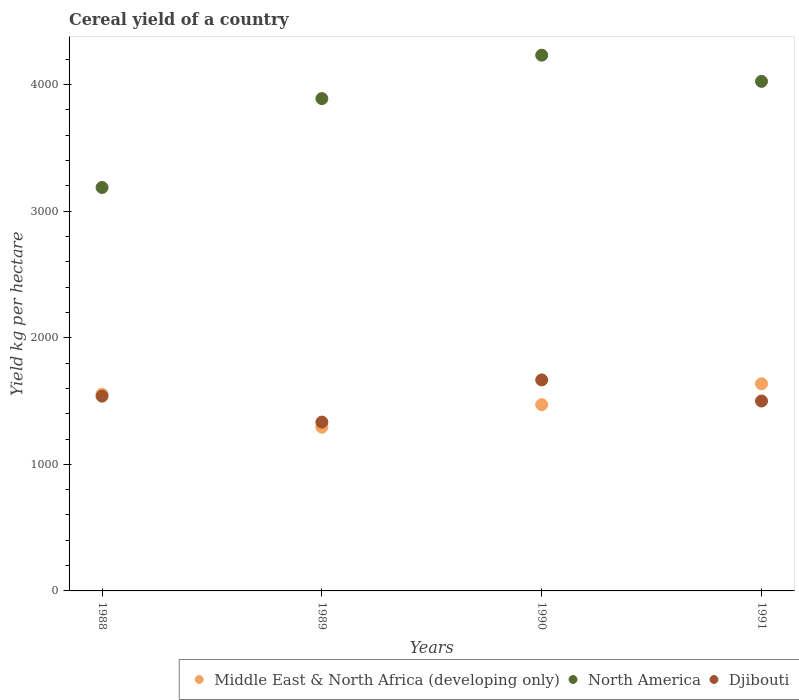Is the number of dotlines equal to the number of legend labels?
Ensure brevity in your answer.  Yes. What is the total cereal yield in Djibouti in 1991?
Offer a very short reply. 1500. Across all years, what is the maximum total cereal yield in Middle East & North Africa (developing only)?
Your answer should be compact. 1636.14. Across all years, what is the minimum total cereal yield in North America?
Offer a terse response. 3186.76. What is the total total cereal yield in North America in the graph?
Give a very brief answer. 1.53e+04. What is the difference between the total cereal yield in Middle East & North Africa (developing only) in 1988 and that in 1991?
Give a very brief answer. -82.48. What is the difference between the total cereal yield in Middle East & North Africa (developing only) in 1991 and the total cereal yield in Djibouti in 1990?
Offer a terse response. -30.53. What is the average total cereal yield in North America per year?
Ensure brevity in your answer.  3833.07. In the year 1991, what is the difference between the total cereal yield in Djibouti and total cereal yield in Middle East & North Africa (developing only)?
Ensure brevity in your answer.  -136.14. In how many years, is the total cereal yield in Middle East & North Africa (developing only) greater than 2200 kg per hectare?
Ensure brevity in your answer.  0. What is the ratio of the total cereal yield in Middle East & North Africa (developing only) in 1989 to that in 1991?
Keep it short and to the point. 0.79. Is the total cereal yield in Middle East & North Africa (developing only) in 1988 less than that in 1990?
Provide a succinct answer. No. Is the difference between the total cereal yield in Djibouti in 1990 and 1991 greater than the difference between the total cereal yield in Middle East & North Africa (developing only) in 1990 and 1991?
Your answer should be very brief. Yes. What is the difference between the highest and the second highest total cereal yield in Djibouti?
Provide a succinct answer. 128.2. What is the difference between the highest and the lowest total cereal yield in North America?
Your response must be concise. 1045.05. In how many years, is the total cereal yield in Djibouti greater than the average total cereal yield in Djibouti taken over all years?
Make the answer very short. 2. Is the sum of the total cereal yield in Djibouti in 1988 and 1990 greater than the maximum total cereal yield in North America across all years?
Give a very brief answer. No. Is the total cereal yield in Djibouti strictly greater than the total cereal yield in Middle East & North Africa (developing only) over the years?
Give a very brief answer. No. Is the total cereal yield in Middle East & North Africa (developing only) strictly less than the total cereal yield in North America over the years?
Ensure brevity in your answer.  Yes. How many years are there in the graph?
Keep it short and to the point. 4. Does the graph contain any zero values?
Provide a short and direct response. No. Does the graph contain grids?
Provide a short and direct response. No. How are the legend labels stacked?
Make the answer very short. Horizontal. What is the title of the graph?
Ensure brevity in your answer.  Cereal yield of a country. Does "Kosovo" appear as one of the legend labels in the graph?
Provide a succinct answer. No. What is the label or title of the Y-axis?
Provide a succinct answer. Yield kg per hectare. What is the Yield kg per hectare of Middle East & North Africa (developing only) in 1988?
Offer a very short reply. 1553.66. What is the Yield kg per hectare in North America in 1988?
Ensure brevity in your answer.  3186.76. What is the Yield kg per hectare of Djibouti in 1988?
Keep it short and to the point. 1538.46. What is the Yield kg per hectare in Middle East & North Africa (developing only) in 1989?
Provide a short and direct response. 1293.52. What is the Yield kg per hectare in North America in 1989?
Offer a very short reply. 3888.9. What is the Yield kg per hectare of Djibouti in 1989?
Offer a terse response. 1333.33. What is the Yield kg per hectare in Middle East & North Africa (developing only) in 1990?
Provide a short and direct response. 1471.14. What is the Yield kg per hectare of North America in 1990?
Your answer should be compact. 4231.81. What is the Yield kg per hectare in Djibouti in 1990?
Your response must be concise. 1666.67. What is the Yield kg per hectare of Middle East & North Africa (developing only) in 1991?
Your answer should be very brief. 1636.14. What is the Yield kg per hectare of North America in 1991?
Provide a short and direct response. 4024.81. What is the Yield kg per hectare in Djibouti in 1991?
Make the answer very short. 1500. Across all years, what is the maximum Yield kg per hectare in Middle East & North Africa (developing only)?
Provide a succinct answer. 1636.14. Across all years, what is the maximum Yield kg per hectare in North America?
Your response must be concise. 4231.81. Across all years, what is the maximum Yield kg per hectare in Djibouti?
Give a very brief answer. 1666.67. Across all years, what is the minimum Yield kg per hectare of Middle East & North Africa (developing only)?
Provide a short and direct response. 1293.52. Across all years, what is the minimum Yield kg per hectare in North America?
Offer a very short reply. 3186.76. Across all years, what is the minimum Yield kg per hectare in Djibouti?
Your answer should be compact. 1333.33. What is the total Yield kg per hectare of Middle East & North Africa (developing only) in the graph?
Your response must be concise. 5954.46. What is the total Yield kg per hectare of North America in the graph?
Give a very brief answer. 1.53e+04. What is the total Yield kg per hectare in Djibouti in the graph?
Give a very brief answer. 6038.46. What is the difference between the Yield kg per hectare of Middle East & North Africa (developing only) in 1988 and that in 1989?
Give a very brief answer. 260.14. What is the difference between the Yield kg per hectare in North America in 1988 and that in 1989?
Your answer should be compact. -702.13. What is the difference between the Yield kg per hectare of Djibouti in 1988 and that in 1989?
Offer a terse response. 205.13. What is the difference between the Yield kg per hectare in Middle East & North Africa (developing only) in 1988 and that in 1990?
Your response must be concise. 82.53. What is the difference between the Yield kg per hectare in North America in 1988 and that in 1990?
Offer a terse response. -1045.05. What is the difference between the Yield kg per hectare in Djibouti in 1988 and that in 1990?
Your answer should be compact. -128.21. What is the difference between the Yield kg per hectare in Middle East & North Africa (developing only) in 1988 and that in 1991?
Give a very brief answer. -82.48. What is the difference between the Yield kg per hectare in North America in 1988 and that in 1991?
Make the answer very short. -838.05. What is the difference between the Yield kg per hectare of Djibouti in 1988 and that in 1991?
Your answer should be very brief. 38.46. What is the difference between the Yield kg per hectare of Middle East & North Africa (developing only) in 1989 and that in 1990?
Keep it short and to the point. -177.61. What is the difference between the Yield kg per hectare in North America in 1989 and that in 1990?
Offer a very short reply. -342.92. What is the difference between the Yield kg per hectare of Djibouti in 1989 and that in 1990?
Give a very brief answer. -333.33. What is the difference between the Yield kg per hectare of Middle East & North Africa (developing only) in 1989 and that in 1991?
Your answer should be very brief. -342.62. What is the difference between the Yield kg per hectare in North America in 1989 and that in 1991?
Your answer should be very brief. -135.91. What is the difference between the Yield kg per hectare of Djibouti in 1989 and that in 1991?
Provide a short and direct response. -166.67. What is the difference between the Yield kg per hectare in Middle East & North Africa (developing only) in 1990 and that in 1991?
Give a very brief answer. -165. What is the difference between the Yield kg per hectare of North America in 1990 and that in 1991?
Keep it short and to the point. 207.01. What is the difference between the Yield kg per hectare in Djibouti in 1990 and that in 1991?
Your response must be concise. 166.67. What is the difference between the Yield kg per hectare in Middle East & North Africa (developing only) in 1988 and the Yield kg per hectare in North America in 1989?
Offer a terse response. -2335.24. What is the difference between the Yield kg per hectare in Middle East & North Africa (developing only) in 1988 and the Yield kg per hectare in Djibouti in 1989?
Give a very brief answer. 220.33. What is the difference between the Yield kg per hectare in North America in 1988 and the Yield kg per hectare in Djibouti in 1989?
Keep it short and to the point. 1853.43. What is the difference between the Yield kg per hectare in Middle East & North Africa (developing only) in 1988 and the Yield kg per hectare in North America in 1990?
Provide a succinct answer. -2678.15. What is the difference between the Yield kg per hectare of Middle East & North Africa (developing only) in 1988 and the Yield kg per hectare of Djibouti in 1990?
Make the answer very short. -113. What is the difference between the Yield kg per hectare of North America in 1988 and the Yield kg per hectare of Djibouti in 1990?
Ensure brevity in your answer.  1520.1. What is the difference between the Yield kg per hectare in Middle East & North Africa (developing only) in 1988 and the Yield kg per hectare in North America in 1991?
Offer a very short reply. -2471.15. What is the difference between the Yield kg per hectare of Middle East & North Africa (developing only) in 1988 and the Yield kg per hectare of Djibouti in 1991?
Make the answer very short. 53.66. What is the difference between the Yield kg per hectare of North America in 1988 and the Yield kg per hectare of Djibouti in 1991?
Offer a terse response. 1686.76. What is the difference between the Yield kg per hectare in Middle East & North Africa (developing only) in 1989 and the Yield kg per hectare in North America in 1990?
Keep it short and to the point. -2938.29. What is the difference between the Yield kg per hectare of Middle East & North Africa (developing only) in 1989 and the Yield kg per hectare of Djibouti in 1990?
Ensure brevity in your answer.  -373.14. What is the difference between the Yield kg per hectare of North America in 1989 and the Yield kg per hectare of Djibouti in 1990?
Offer a terse response. 2222.23. What is the difference between the Yield kg per hectare of Middle East & North Africa (developing only) in 1989 and the Yield kg per hectare of North America in 1991?
Your answer should be compact. -2731.29. What is the difference between the Yield kg per hectare of Middle East & North Africa (developing only) in 1989 and the Yield kg per hectare of Djibouti in 1991?
Your answer should be very brief. -206.48. What is the difference between the Yield kg per hectare in North America in 1989 and the Yield kg per hectare in Djibouti in 1991?
Your response must be concise. 2388.9. What is the difference between the Yield kg per hectare of Middle East & North Africa (developing only) in 1990 and the Yield kg per hectare of North America in 1991?
Keep it short and to the point. -2553.67. What is the difference between the Yield kg per hectare of Middle East & North Africa (developing only) in 1990 and the Yield kg per hectare of Djibouti in 1991?
Ensure brevity in your answer.  -28.86. What is the difference between the Yield kg per hectare of North America in 1990 and the Yield kg per hectare of Djibouti in 1991?
Your response must be concise. 2731.81. What is the average Yield kg per hectare of Middle East & North Africa (developing only) per year?
Make the answer very short. 1488.62. What is the average Yield kg per hectare of North America per year?
Ensure brevity in your answer.  3833.07. What is the average Yield kg per hectare in Djibouti per year?
Provide a short and direct response. 1509.62. In the year 1988, what is the difference between the Yield kg per hectare of Middle East & North Africa (developing only) and Yield kg per hectare of North America?
Your response must be concise. -1633.1. In the year 1988, what is the difference between the Yield kg per hectare in Middle East & North Africa (developing only) and Yield kg per hectare in Djibouti?
Provide a short and direct response. 15.2. In the year 1988, what is the difference between the Yield kg per hectare in North America and Yield kg per hectare in Djibouti?
Ensure brevity in your answer.  1648.3. In the year 1989, what is the difference between the Yield kg per hectare in Middle East & North Africa (developing only) and Yield kg per hectare in North America?
Your response must be concise. -2595.37. In the year 1989, what is the difference between the Yield kg per hectare in Middle East & North Africa (developing only) and Yield kg per hectare in Djibouti?
Provide a succinct answer. -39.81. In the year 1989, what is the difference between the Yield kg per hectare of North America and Yield kg per hectare of Djibouti?
Ensure brevity in your answer.  2555.57. In the year 1990, what is the difference between the Yield kg per hectare in Middle East & North Africa (developing only) and Yield kg per hectare in North America?
Ensure brevity in your answer.  -2760.68. In the year 1990, what is the difference between the Yield kg per hectare of Middle East & North Africa (developing only) and Yield kg per hectare of Djibouti?
Offer a very short reply. -195.53. In the year 1990, what is the difference between the Yield kg per hectare of North America and Yield kg per hectare of Djibouti?
Provide a short and direct response. 2565.15. In the year 1991, what is the difference between the Yield kg per hectare of Middle East & North Africa (developing only) and Yield kg per hectare of North America?
Make the answer very short. -2388.67. In the year 1991, what is the difference between the Yield kg per hectare in Middle East & North Africa (developing only) and Yield kg per hectare in Djibouti?
Provide a succinct answer. 136.14. In the year 1991, what is the difference between the Yield kg per hectare of North America and Yield kg per hectare of Djibouti?
Make the answer very short. 2524.81. What is the ratio of the Yield kg per hectare of Middle East & North Africa (developing only) in 1988 to that in 1989?
Provide a short and direct response. 1.2. What is the ratio of the Yield kg per hectare of North America in 1988 to that in 1989?
Give a very brief answer. 0.82. What is the ratio of the Yield kg per hectare of Djibouti in 1988 to that in 1989?
Ensure brevity in your answer.  1.15. What is the ratio of the Yield kg per hectare in Middle East & North Africa (developing only) in 1988 to that in 1990?
Provide a short and direct response. 1.06. What is the ratio of the Yield kg per hectare of North America in 1988 to that in 1990?
Ensure brevity in your answer.  0.75. What is the ratio of the Yield kg per hectare of Djibouti in 1988 to that in 1990?
Ensure brevity in your answer.  0.92. What is the ratio of the Yield kg per hectare of Middle East & North Africa (developing only) in 1988 to that in 1991?
Ensure brevity in your answer.  0.95. What is the ratio of the Yield kg per hectare in North America in 1988 to that in 1991?
Ensure brevity in your answer.  0.79. What is the ratio of the Yield kg per hectare in Djibouti in 1988 to that in 1991?
Your answer should be compact. 1.03. What is the ratio of the Yield kg per hectare of Middle East & North Africa (developing only) in 1989 to that in 1990?
Provide a succinct answer. 0.88. What is the ratio of the Yield kg per hectare of North America in 1989 to that in 1990?
Offer a terse response. 0.92. What is the ratio of the Yield kg per hectare of Djibouti in 1989 to that in 1990?
Your answer should be compact. 0.8. What is the ratio of the Yield kg per hectare of Middle East & North Africa (developing only) in 1989 to that in 1991?
Provide a short and direct response. 0.79. What is the ratio of the Yield kg per hectare of North America in 1989 to that in 1991?
Provide a succinct answer. 0.97. What is the ratio of the Yield kg per hectare of Djibouti in 1989 to that in 1991?
Offer a very short reply. 0.89. What is the ratio of the Yield kg per hectare of Middle East & North Africa (developing only) in 1990 to that in 1991?
Offer a very short reply. 0.9. What is the ratio of the Yield kg per hectare of North America in 1990 to that in 1991?
Your response must be concise. 1.05. What is the ratio of the Yield kg per hectare of Djibouti in 1990 to that in 1991?
Provide a succinct answer. 1.11. What is the difference between the highest and the second highest Yield kg per hectare in Middle East & North Africa (developing only)?
Give a very brief answer. 82.48. What is the difference between the highest and the second highest Yield kg per hectare in North America?
Keep it short and to the point. 207.01. What is the difference between the highest and the second highest Yield kg per hectare of Djibouti?
Offer a terse response. 128.21. What is the difference between the highest and the lowest Yield kg per hectare in Middle East & North Africa (developing only)?
Offer a very short reply. 342.62. What is the difference between the highest and the lowest Yield kg per hectare in North America?
Your response must be concise. 1045.05. What is the difference between the highest and the lowest Yield kg per hectare in Djibouti?
Your answer should be compact. 333.33. 